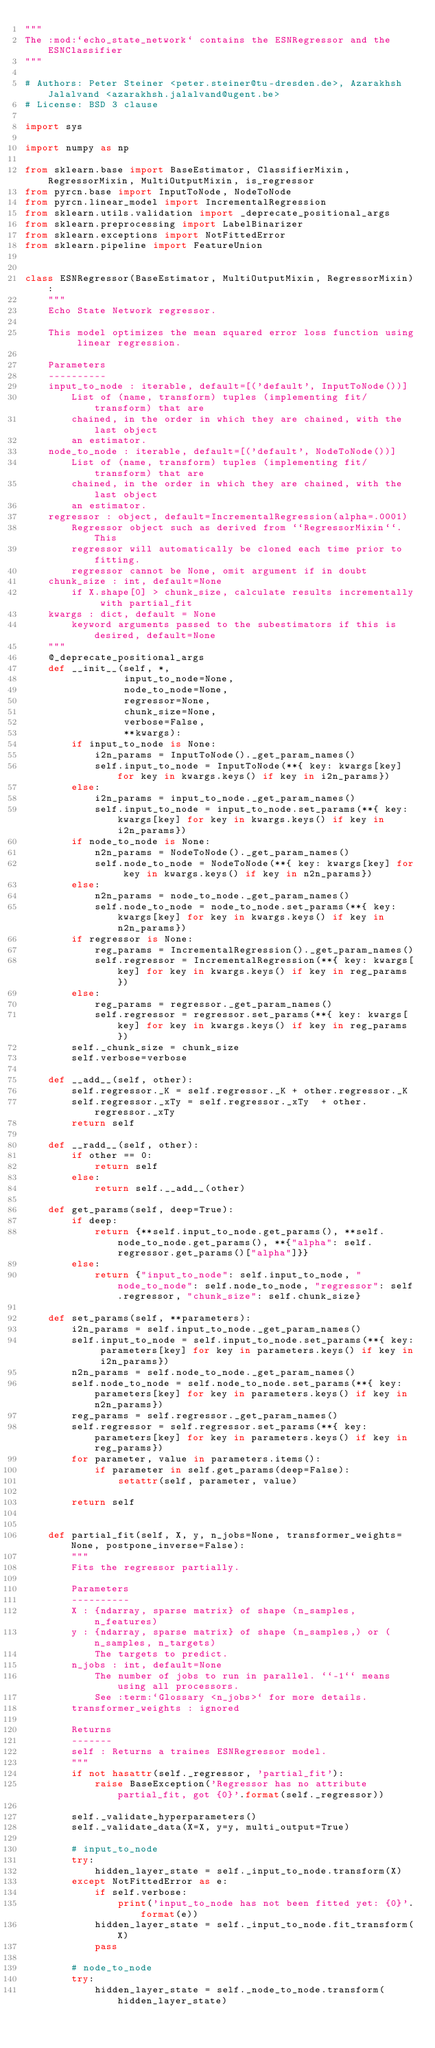<code> <loc_0><loc_0><loc_500><loc_500><_Python_>"""
The :mod:`echo_state_network` contains the ESNRegressor and the ESNClassifier
"""

# Authors: Peter Steiner <peter.steiner@tu-dresden.de>, Azarakhsh Jalalvand <azarakhsh.jalalvand@ugent.be>
# License: BSD 3 clause

import sys

import numpy as np

from sklearn.base import BaseEstimator, ClassifierMixin, RegressorMixin, MultiOutputMixin, is_regressor
from pyrcn.base import InputToNode, NodeToNode
from pyrcn.linear_model import IncrementalRegression
from sklearn.utils.validation import _deprecate_positional_args
from sklearn.preprocessing import LabelBinarizer
from sklearn.exceptions import NotFittedError
from sklearn.pipeline import FeatureUnion


class ESNRegressor(BaseEstimator, MultiOutputMixin, RegressorMixin):
    """
    Echo State Network regressor.

    This model optimizes the mean squared error loss function using linear regression.

    Parameters
    ----------
    input_to_node : iterable, default=[('default', InputToNode())]
        List of (name, transform) tuples (implementing fit/transform) that are
        chained, in the order in which they are chained, with the last object
        an estimator.
    node_to_node : iterable, default=[('default', NodeToNode())]
        List of (name, transform) tuples (implementing fit/transform) that are
        chained, in the order in which they are chained, with the last object
        an estimator.
    regressor : object, default=IncrementalRegression(alpha=.0001)
        Regressor object such as derived from ``RegressorMixin``. This
        regressor will automatically be cloned each time prior to fitting.
        regressor cannot be None, omit argument if in doubt
    chunk_size : int, default=None
        if X.shape[0] > chunk_size, calculate results incrementally with partial_fit
    kwargs : dict, default = None
        keyword arguments passed to the subestimators if this is desired, default=None
    """
    @_deprecate_positional_args
    def __init__(self, *,
                 input_to_node=None,
                 node_to_node=None,
                 regressor=None,
                 chunk_size=None,
                 verbose=False,
                 **kwargs):
        if input_to_node is None:
            i2n_params = InputToNode()._get_param_names()
            self.input_to_node = InputToNode(**{ key: kwargs[key] for key in kwargs.keys() if key in i2n_params})
        else:
            i2n_params = input_to_node._get_param_names()
            self.input_to_node = input_to_node.set_params(**{ key: kwargs[key] for key in kwargs.keys() if key in i2n_params})
        if node_to_node is None:
            n2n_params = NodeToNode()._get_param_names()
            self.node_to_node = NodeToNode(**{ key: kwargs[key] for key in kwargs.keys() if key in n2n_params})
        else:
            n2n_params = node_to_node._get_param_names()
            self.node_to_node = node_to_node.set_params(**{ key: kwargs[key] for key in kwargs.keys() if key in n2n_params})
        if regressor is None:
            reg_params = IncrementalRegression()._get_param_names()
            self.regressor = IncrementalRegression(**{ key: kwargs[key] for key in kwargs.keys() if key in reg_params})
        else:
            reg_params = regressor._get_param_names()
            self.regressor = regressor.set_params(**{ key: kwargs[key] for key in kwargs.keys() if key in reg_params})
        self._chunk_size = chunk_size
        self.verbose=verbose

    def __add__(self, other):
        self.regressor._K = self.regressor._K + other.regressor._K
        self.regressor._xTy = self.regressor._xTy  + other.regressor._xTy
        return self

    def __radd__(self, other):
        if other == 0:
            return self
        else:
            return self.__add__(other)

    def get_params(self, deep=True):
        if deep:
            return {**self.input_to_node.get_params(), **self.node_to_node.get_params(), **{"alpha": self.regressor.get_params()["alpha"]}}
        else:
            return {"input_to_node": self.input_to_node, "node_to_node": self.node_to_node, "regressor": self.regressor, "chunk_size": self.chunk_size}

    def set_params(self, **parameters):
        i2n_params = self.input_to_node._get_param_names()
        self.input_to_node = self.input_to_node.set_params(**{ key: parameters[key] for key in parameters.keys() if key in i2n_params})
        n2n_params = self.node_to_node._get_param_names()
        self.node_to_node = self.node_to_node.set_params(**{ key: parameters[key] for key in parameters.keys() if key in n2n_params})
        reg_params = self.regressor._get_param_names()
        self.regressor = self.regressor.set_params(**{ key: parameters[key] for key in parameters.keys() if key in reg_params})
        for parameter, value in parameters.items():
            if parameter in self.get_params(deep=False):
                setattr(self, parameter, value)

        return self


    def partial_fit(self, X, y, n_jobs=None, transformer_weights=None, postpone_inverse=False):
        """
        Fits the regressor partially.

        Parameters
        ----------
        X : {ndarray, sparse matrix} of shape (n_samples, n_features)
        y : {ndarray, sparse matrix} of shape (n_samples,) or (n_samples, n_targets)
            The targets to predict.
        n_jobs : int, default=None
            The number of jobs to run in parallel. ``-1`` means using all processors.
            See :term:`Glossary <n_jobs>` for more details.
        transformer_weights : ignored

        Returns
        -------
        self : Returns a traines ESNRegressor model.
        """
        if not hasattr(self._regressor, 'partial_fit'):
            raise BaseException('Regressor has no attribute partial_fit, got {0}'.format(self._regressor))

        self._validate_hyperparameters()
        self._validate_data(X=X, y=y, multi_output=True)

        # input_to_node
        try:
            hidden_layer_state = self._input_to_node.transform(X)
        except NotFittedError as e:
            if self.verbose:
                print('input_to_node has not been fitted yet: {0}'.format(e))
            hidden_layer_state = self._input_to_node.fit_transform(X)
            pass

        # node_to_node
        try:
            hidden_layer_state = self._node_to_node.transform(hidden_layer_state)</code> 